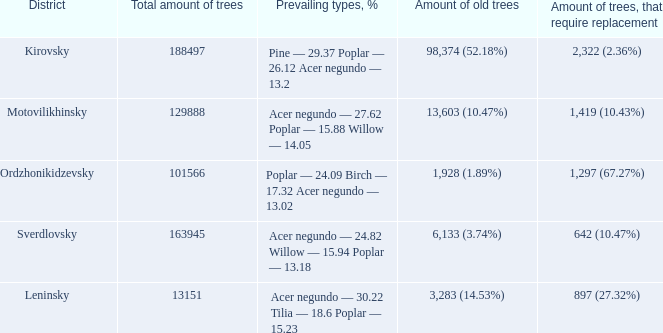37 poplar - 2 2,322 (2.36%). 